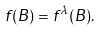Convert formula to latex. <formula><loc_0><loc_0><loc_500><loc_500>f ( B ) & = f ^ { \lambda } ( B ) .</formula> 